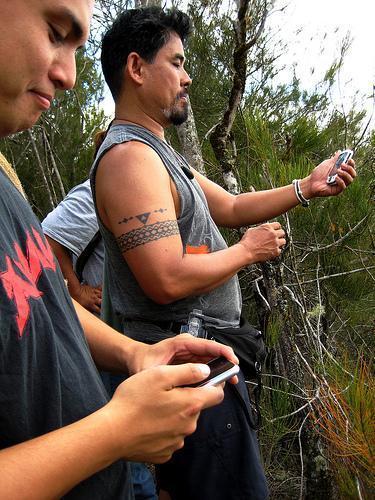How many men in the picture?
Give a very brief answer. 3. 